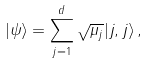<formula> <loc_0><loc_0><loc_500><loc_500>| \psi \rangle = \sum _ { j = 1 } ^ { d } \sqrt { \mu _ { j } } | j , j \rangle \, ,</formula> 